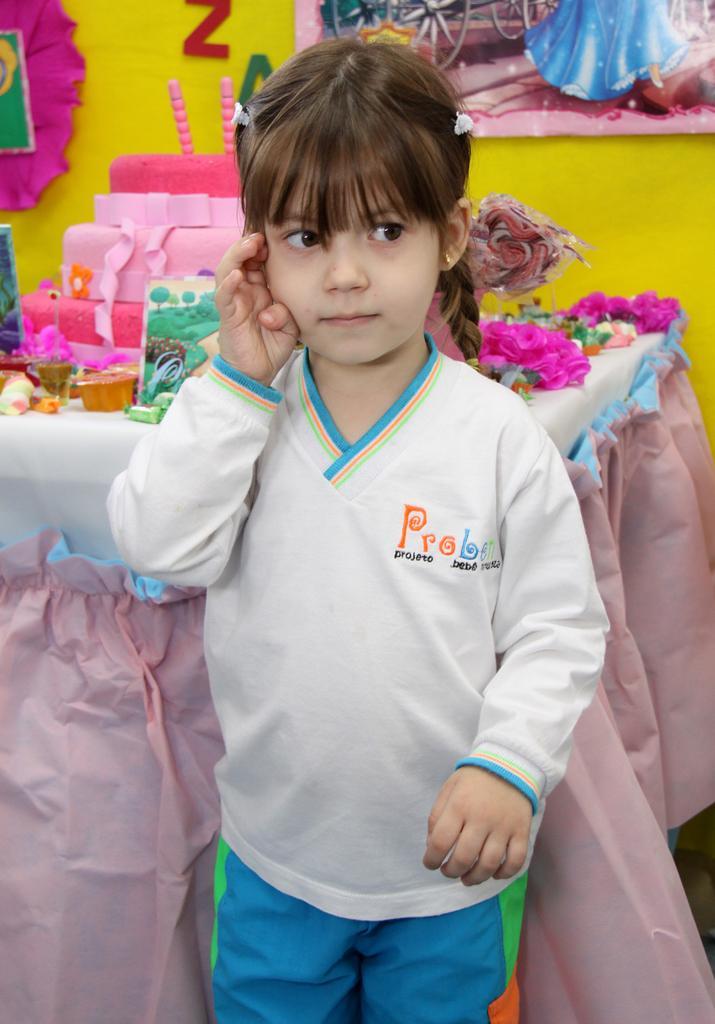Describe this image in one or two sentences. In this image, we can see a kid standing and there is a table, there are some objects placed on the table, we can see a yellow wall. 